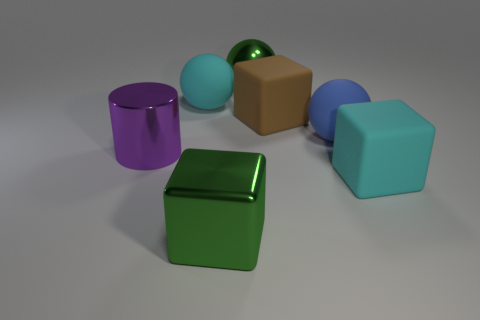Can you describe the texture of the objects present in the image? Certainly! All the objects in the image have a smooth and matte texture. The light reflects gently on their surfaces, suggesting they are not shiny, but rather have a consistent, non-glossy appearance. 